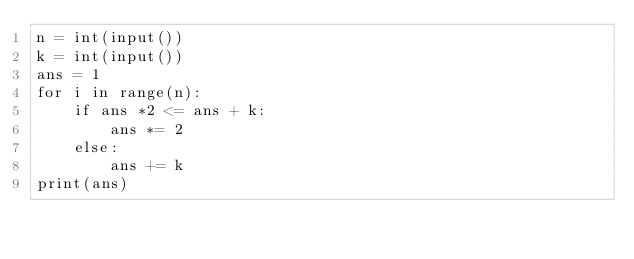<code> <loc_0><loc_0><loc_500><loc_500><_Python_>n = int(input())
k = int(input())
ans = 1
for i in range(n):
    if ans *2 <= ans + k:
        ans *= 2
    else:
        ans += k
print(ans)</code> 